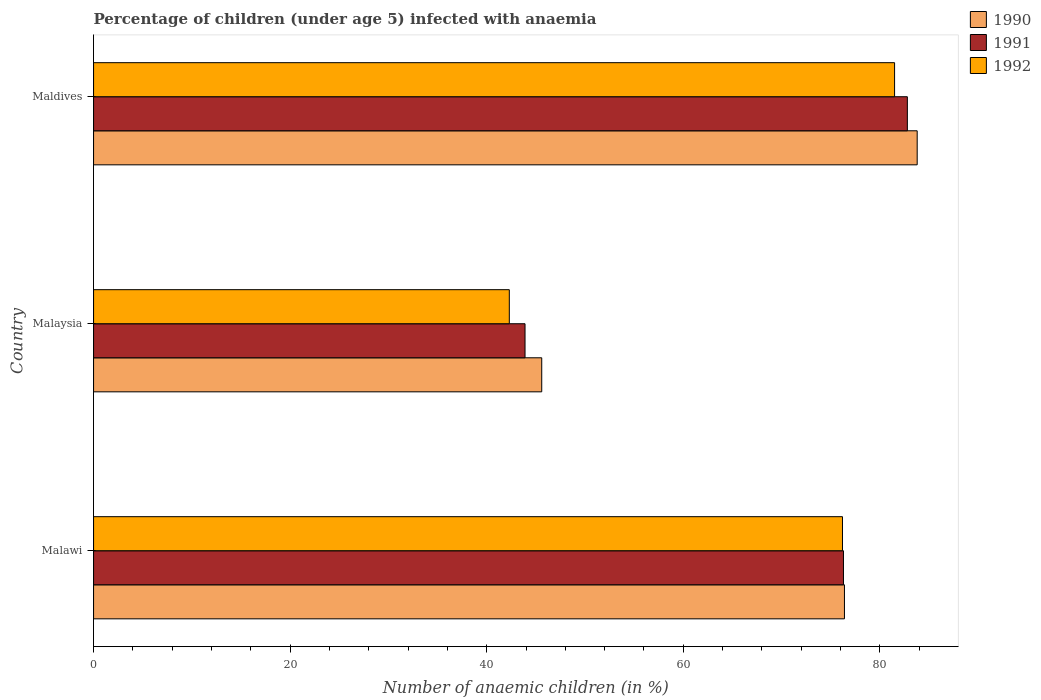How many bars are there on the 1st tick from the bottom?
Your answer should be very brief. 3. What is the label of the 2nd group of bars from the top?
Provide a succinct answer. Malaysia. In how many cases, is the number of bars for a given country not equal to the number of legend labels?
Offer a terse response. 0. What is the percentage of children infected with anaemia in in 1992 in Malaysia?
Your answer should be compact. 42.3. Across all countries, what is the maximum percentage of children infected with anaemia in in 1990?
Provide a succinct answer. 83.8. Across all countries, what is the minimum percentage of children infected with anaemia in in 1992?
Keep it short and to the point. 42.3. In which country was the percentage of children infected with anaemia in in 1991 maximum?
Offer a very short reply. Maldives. In which country was the percentage of children infected with anaemia in in 1990 minimum?
Give a very brief answer. Malaysia. What is the total percentage of children infected with anaemia in in 1992 in the graph?
Your answer should be very brief. 200. What is the difference between the percentage of children infected with anaemia in in 1992 in Malawi and the percentage of children infected with anaemia in in 1991 in Malaysia?
Your response must be concise. 32.3. What is the average percentage of children infected with anaemia in in 1992 per country?
Your response must be concise. 66.67. What is the difference between the percentage of children infected with anaemia in in 1991 and percentage of children infected with anaemia in in 1990 in Maldives?
Your response must be concise. -1. What is the ratio of the percentage of children infected with anaemia in in 1991 in Malaysia to that in Maldives?
Provide a succinct answer. 0.53. Is the percentage of children infected with anaemia in in 1992 in Malaysia less than that in Maldives?
Make the answer very short. Yes. Is the difference between the percentage of children infected with anaemia in in 1991 in Malaysia and Maldives greater than the difference between the percentage of children infected with anaemia in in 1990 in Malaysia and Maldives?
Your response must be concise. No. What is the difference between the highest and the second highest percentage of children infected with anaemia in in 1990?
Give a very brief answer. 7.4. What is the difference between the highest and the lowest percentage of children infected with anaemia in in 1991?
Make the answer very short. 38.9. Are all the bars in the graph horizontal?
Offer a terse response. Yes. How many countries are there in the graph?
Provide a short and direct response. 3. Does the graph contain grids?
Ensure brevity in your answer.  No. Where does the legend appear in the graph?
Keep it short and to the point. Top right. How many legend labels are there?
Offer a very short reply. 3. How are the legend labels stacked?
Offer a terse response. Vertical. What is the title of the graph?
Offer a very short reply. Percentage of children (under age 5) infected with anaemia. What is the label or title of the X-axis?
Your response must be concise. Number of anaemic children (in %). What is the label or title of the Y-axis?
Your answer should be very brief. Country. What is the Number of anaemic children (in %) of 1990 in Malawi?
Provide a short and direct response. 76.4. What is the Number of anaemic children (in %) of 1991 in Malawi?
Offer a terse response. 76.3. What is the Number of anaemic children (in %) in 1992 in Malawi?
Provide a short and direct response. 76.2. What is the Number of anaemic children (in %) of 1990 in Malaysia?
Ensure brevity in your answer.  45.6. What is the Number of anaemic children (in %) in 1991 in Malaysia?
Provide a short and direct response. 43.9. What is the Number of anaemic children (in %) in 1992 in Malaysia?
Your response must be concise. 42.3. What is the Number of anaemic children (in %) in 1990 in Maldives?
Your answer should be very brief. 83.8. What is the Number of anaemic children (in %) of 1991 in Maldives?
Offer a very short reply. 82.8. What is the Number of anaemic children (in %) of 1992 in Maldives?
Your answer should be very brief. 81.5. Across all countries, what is the maximum Number of anaemic children (in %) in 1990?
Ensure brevity in your answer.  83.8. Across all countries, what is the maximum Number of anaemic children (in %) of 1991?
Offer a very short reply. 82.8. Across all countries, what is the maximum Number of anaemic children (in %) in 1992?
Your response must be concise. 81.5. Across all countries, what is the minimum Number of anaemic children (in %) in 1990?
Provide a succinct answer. 45.6. Across all countries, what is the minimum Number of anaemic children (in %) in 1991?
Your answer should be compact. 43.9. Across all countries, what is the minimum Number of anaemic children (in %) of 1992?
Your response must be concise. 42.3. What is the total Number of anaemic children (in %) of 1990 in the graph?
Your answer should be very brief. 205.8. What is the total Number of anaemic children (in %) in 1991 in the graph?
Offer a terse response. 203. What is the difference between the Number of anaemic children (in %) of 1990 in Malawi and that in Malaysia?
Ensure brevity in your answer.  30.8. What is the difference between the Number of anaemic children (in %) in 1991 in Malawi and that in Malaysia?
Offer a very short reply. 32.4. What is the difference between the Number of anaemic children (in %) in 1992 in Malawi and that in Malaysia?
Offer a terse response. 33.9. What is the difference between the Number of anaemic children (in %) of 1990 in Malawi and that in Maldives?
Keep it short and to the point. -7.4. What is the difference between the Number of anaemic children (in %) of 1991 in Malawi and that in Maldives?
Offer a terse response. -6.5. What is the difference between the Number of anaemic children (in %) of 1992 in Malawi and that in Maldives?
Offer a very short reply. -5.3. What is the difference between the Number of anaemic children (in %) of 1990 in Malaysia and that in Maldives?
Offer a very short reply. -38.2. What is the difference between the Number of anaemic children (in %) of 1991 in Malaysia and that in Maldives?
Your answer should be compact. -38.9. What is the difference between the Number of anaemic children (in %) in 1992 in Malaysia and that in Maldives?
Provide a short and direct response. -39.2. What is the difference between the Number of anaemic children (in %) in 1990 in Malawi and the Number of anaemic children (in %) in 1991 in Malaysia?
Your response must be concise. 32.5. What is the difference between the Number of anaemic children (in %) of 1990 in Malawi and the Number of anaemic children (in %) of 1992 in Malaysia?
Make the answer very short. 34.1. What is the difference between the Number of anaemic children (in %) in 1990 in Malawi and the Number of anaemic children (in %) in 1991 in Maldives?
Provide a short and direct response. -6.4. What is the difference between the Number of anaemic children (in %) of 1991 in Malawi and the Number of anaemic children (in %) of 1992 in Maldives?
Your response must be concise. -5.2. What is the difference between the Number of anaemic children (in %) of 1990 in Malaysia and the Number of anaemic children (in %) of 1991 in Maldives?
Your response must be concise. -37.2. What is the difference between the Number of anaemic children (in %) of 1990 in Malaysia and the Number of anaemic children (in %) of 1992 in Maldives?
Offer a terse response. -35.9. What is the difference between the Number of anaemic children (in %) in 1991 in Malaysia and the Number of anaemic children (in %) in 1992 in Maldives?
Offer a terse response. -37.6. What is the average Number of anaemic children (in %) of 1990 per country?
Offer a very short reply. 68.6. What is the average Number of anaemic children (in %) in 1991 per country?
Provide a succinct answer. 67.67. What is the average Number of anaemic children (in %) in 1992 per country?
Offer a terse response. 66.67. What is the difference between the Number of anaemic children (in %) of 1990 and Number of anaemic children (in %) of 1991 in Malawi?
Offer a very short reply. 0.1. What is the difference between the Number of anaemic children (in %) in 1990 and Number of anaemic children (in %) in 1992 in Malawi?
Give a very brief answer. 0.2. What is the difference between the Number of anaemic children (in %) in 1991 and Number of anaemic children (in %) in 1992 in Malawi?
Offer a terse response. 0.1. What is the difference between the Number of anaemic children (in %) of 1990 and Number of anaemic children (in %) of 1991 in Malaysia?
Your answer should be very brief. 1.7. What is the difference between the Number of anaemic children (in %) in 1990 and Number of anaemic children (in %) in 1992 in Malaysia?
Provide a succinct answer. 3.3. What is the difference between the Number of anaemic children (in %) of 1990 and Number of anaemic children (in %) of 1991 in Maldives?
Give a very brief answer. 1. What is the difference between the Number of anaemic children (in %) in 1991 and Number of anaemic children (in %) in 1992 in Maldives?
Your response must be concise. 1.3. What is the ratio of the Number of anaemic children (in %) of 1990 in Malawi to that in Malaysia?
Your answer should be very brief. 1.68. What is the ratio of the Number of anaemic children (in %) of 1991 in Malawi to that in Malaysia?
Provide a short and direct response. 1.74. What is the ratio of the Number of anaemic children (in %) in 1992 in Malawi to that in Malaysia?
Ensure brevity in your answer.  1.8. What is the ratio of the Number of anaemic children (in %) of 1990 in Malawi to that in Maldives?
Give a very brief answer. 0.91. What is the ratio of the Number of anaemic children (in %) of 1991 in Malawi to that in Maldives?
Offer a very short reply. 0.92. What is the ratio of the Number of anaemic children (in %) of 1992 in Malawi to that in Maldives?
Offer a terse response. 0.94. What is the ratio of the Number of anaemic children (in %) of 1990 in Malaysia to that in Maldives?
Offer a terse response. 0.54. What is the ratio of the Number of anaemic children (in %) in 1991 in Malaysia to that in Maldives?
Your answer should be very brief. 0.53. What is the ratio of the Number of anaemic children (in %) in 1992 in Malaysia to that in Maldives?
Give a very brief answer. 0.52. What is the difference between the highest and the second highest Number of anaemic children (in %) of 1990?
Provide a short and direct response. 7.4. What is the difference between the highest and the second highest Number of anaemic children (in %) in 1991?
Provide a short and direct response. 6.5. What is the difference between the highest and the second highest Number of anaemic children (in %) in 1992?
Your response must be concise. 5.3. What is the difference between the highest and the lowest Number of anaemic children (in %) of 1990?
Make the answer very short. 38.2. What is the difference between the highest and the lowest Number of anaemic children (in %) in 1991?
Provide a short and direct response. 38.9. What is the difference between the highest and the lowest Number of anaemic children (in %) in 1992?
Your answer should be very brief. 39.2. 